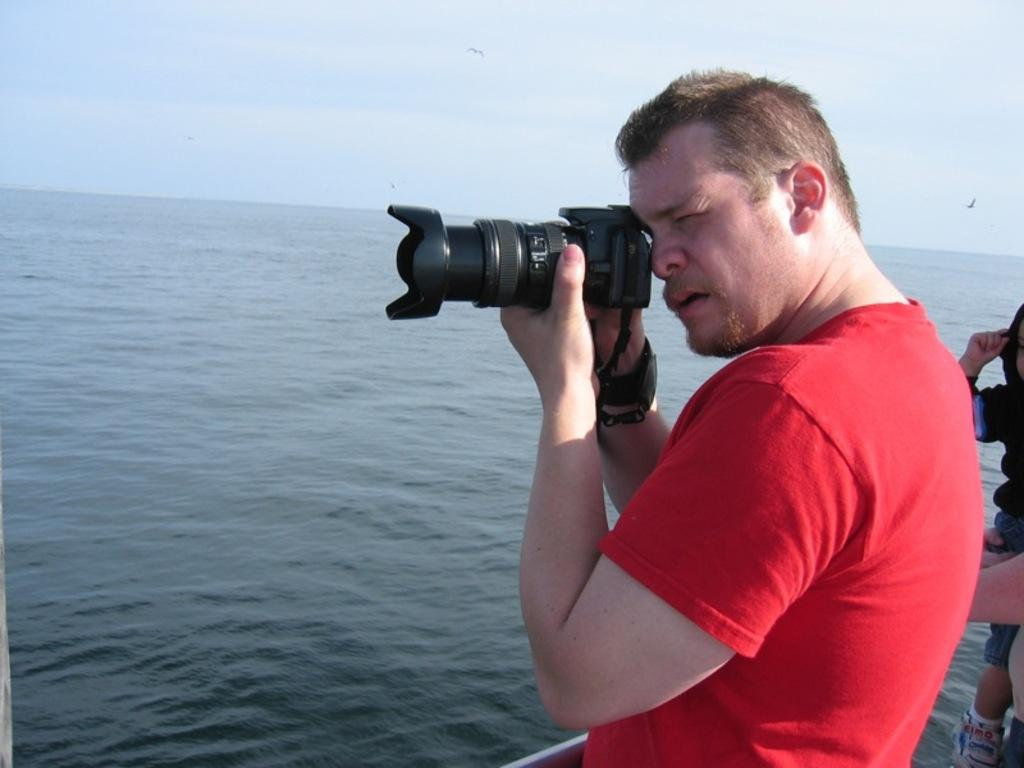What is the person in the image wearing? The person is wearing a red t-shirt in the image. What is the person holding in the image? The person is holding a camera in the image. What is the person doing with the camera? The person is taking a picture in the image. What can be seen in the background of the image? Water and sky are visible in the background of the image. Can you describe the activity happening on the right side of the image? There is a person holding a child in the right side of the image. How many girls are ploughing the field in the image? There are no girls or ploughs present in the image. What type of harbor can be seen in the image? There is no harbor visible in the image. 